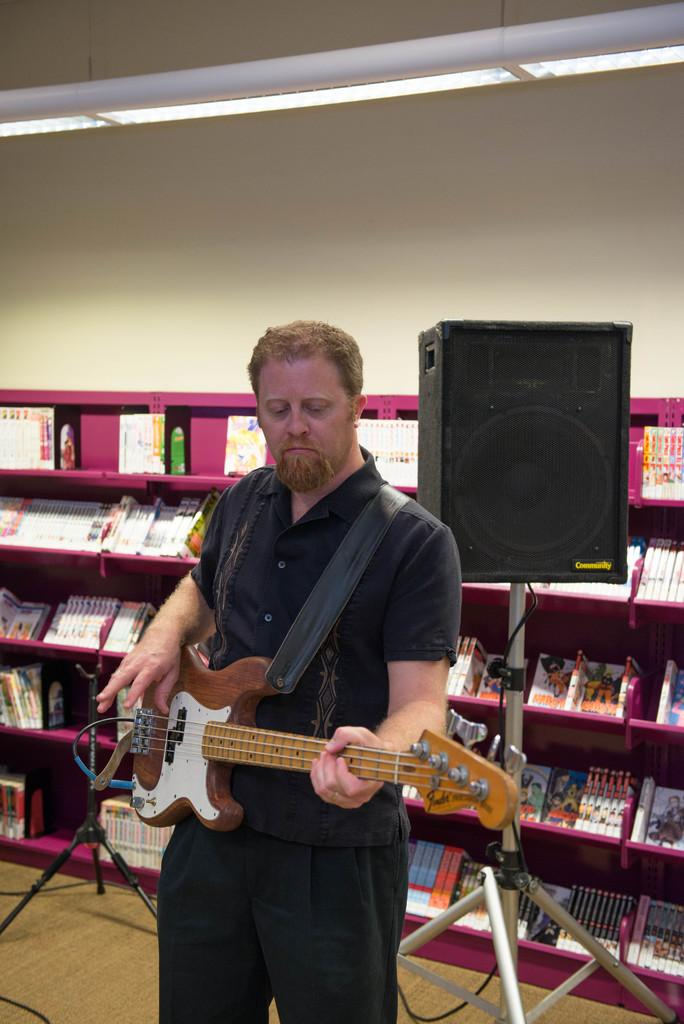What is the man in the image holding? The man is holding a guitar. Can you describe the guitar in more detail? The guitar has a sound box with a stand. What else can be seen in the image besides the man and the guitar? There is a rack with things and books in the image. What type of milk is being poured from the roof in the image? There is no milk or roof present in the image; it features a man holding a guitar with a sound box and stand, and a rack with things and books. 